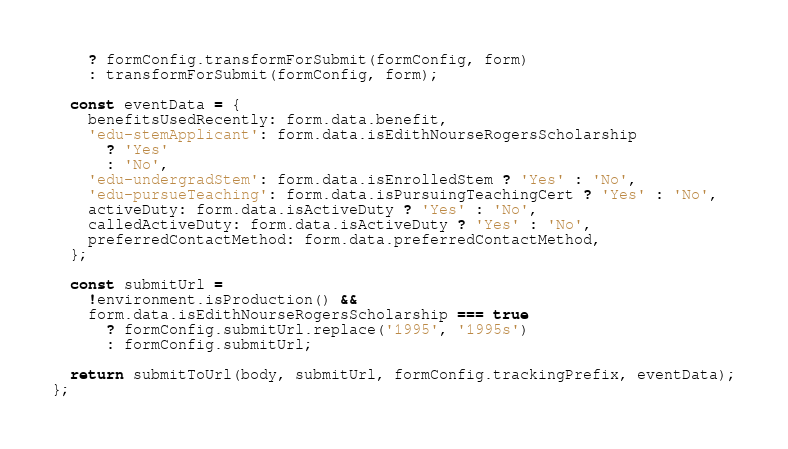Convert code to text. <code><loc_0><loc_0><loc_500><loc_500><_JavaScript_>    ? formConfig.transformForSubmit(formConfig, form)
    : transformForSubmit(formConfig, form);

  const eventData = {
    benefitsUsedRecently: form.data.benefit,
    'edu-stemApplicant': form.data.isEdithNourseRogersScholarship
      ? 'Yes'
      : 'No',
    'edu-undergradStem': form.data.isEnrolledStem ? 'Yes' : 'No',
    'edu-pursueTeaching': form.data.isPursuingTeachingCert ? 'Yes' : 'No',
    activeDuty: form.data.isActiveDuty ? 'Yes' : 'No',
    calledActiveDuty: form.data.isActiveDuty ? 'Yes' : 'No',
    preferredContactMethod: form.data.preferredContactMethod,
  };

  const submitUrl =
    !environment.isProduction() &&
    form.data.isEdithNourseRogersScholarship === true
      ? formConfig.submitUrl.replace('1995', '1995s')
      : formConfig.submitUrl;

  return submitToUrl(body, submitUrl, formConfig.trackingPrefix, eventData);
};
</code> 